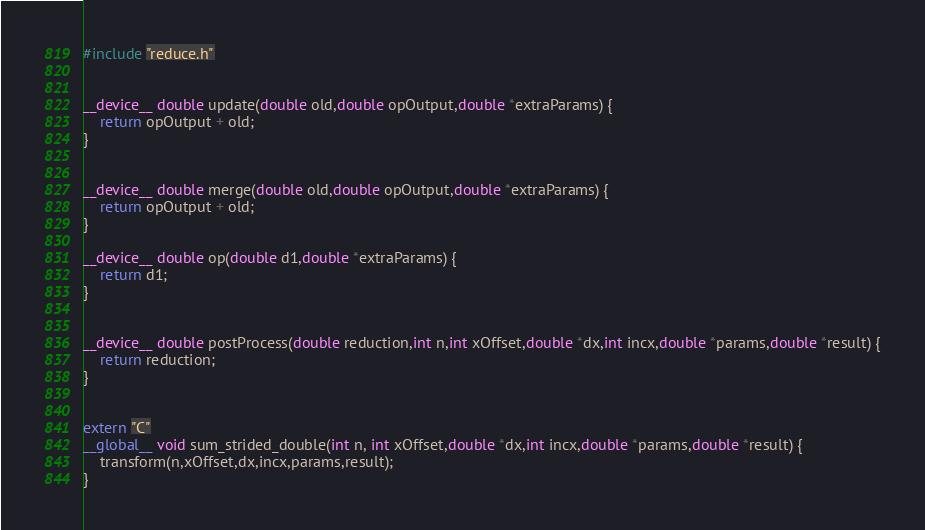<code> <loc_0><loc_0><loc_500><loc_500><_Cuda_>#include "reduce.h"


__device__ double update(double old,double opOutput,double *extraParams) {
	return opOutput + old;
}


__device__ double merge(double old,double opOutput,double *extraParams) {
	return opOutput + old;
}

__device__ double op(double d1,double *extraParams) {
	return d1;
}


__device__ double postProcess(double reduction,int n,int xOffset,double *dx,int incx,double *params,double *result) {
	return reduction;
}


extern "C"
__global__ void sum_strided_double(int n, int xOffset,double *dx,int incx,double *params,double *result) {
	transform(n,xOffset,dx,incx,params,result);
}
</code> 